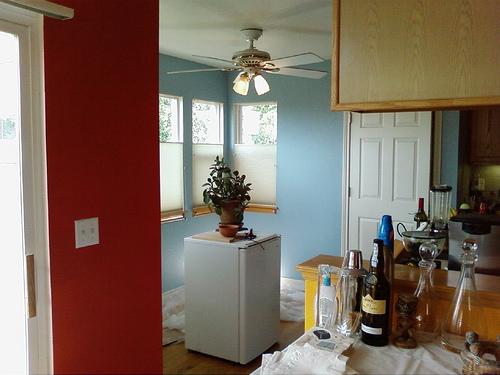Is the wall red?
Keep it brief. Yes. What is on the fridge?
Answer briefly. Plant. Is there a fan in the room?
Quick response, please. Yes. 